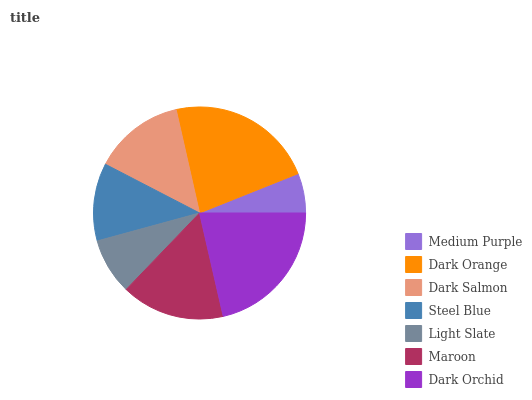Is Medium Purple the minimum?
Answer yes or no. Yes. Is Dark Orange the maximum?
Answer yes or no. Yes. Is Dark Salmon the minimum?
Answer yes or no. No. Is Dark Salmon the maximum?
Answer yes or no. No. Is Dark Orange greater than Dark Salmon?
Answer yes or no. Yes. Is Dark Salmon less than Dark Orange?
Answer yes or no. Yes. Is Dark Salmon greater than Dark Orange?
Answer yes or no. No. Is Dark Orange less than Dark Salmon?
Answer yes or no. No. Is Dark Salmon the high median?
Answer yes or no. Yes. Is Dark Salmon the low median?
Answer yes or no. Yes. Is Dark Orchid the high median?
Answer yes or no. No. Is Maroon the low median?
Answer yes or no. No. 